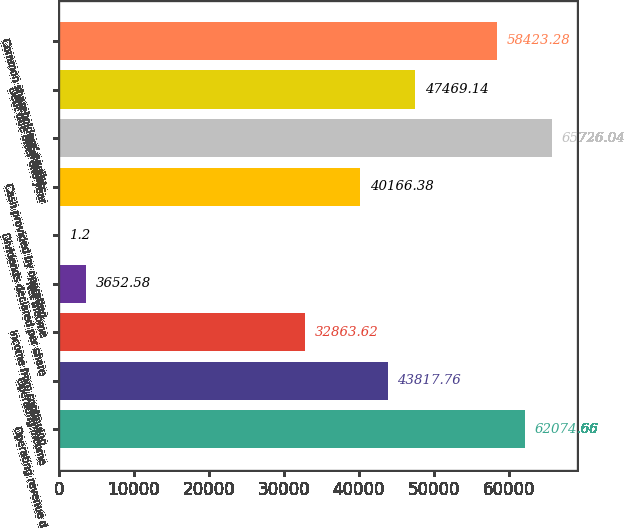<chart> <loc_0><loc_0><loc_500><loc_500><bar_chart><fcel>Operating revenue d<fcel>Operating income<fcel>Income from continuing<fcel>Net income<fcel>Dividends declared per share<fcel>Cash provided by operating<fcel>Total assets<fcel>Debt due after one year<fcel>Common shareholders' equity<nl><fcel>62074.7<fcel>43817.8<fcel>32863.6<fcel>3652.58<fcel>1.2<fcel>40166.4<fcel>65726<fcel>47469.1<fcel>58423.3<nl></chart> 